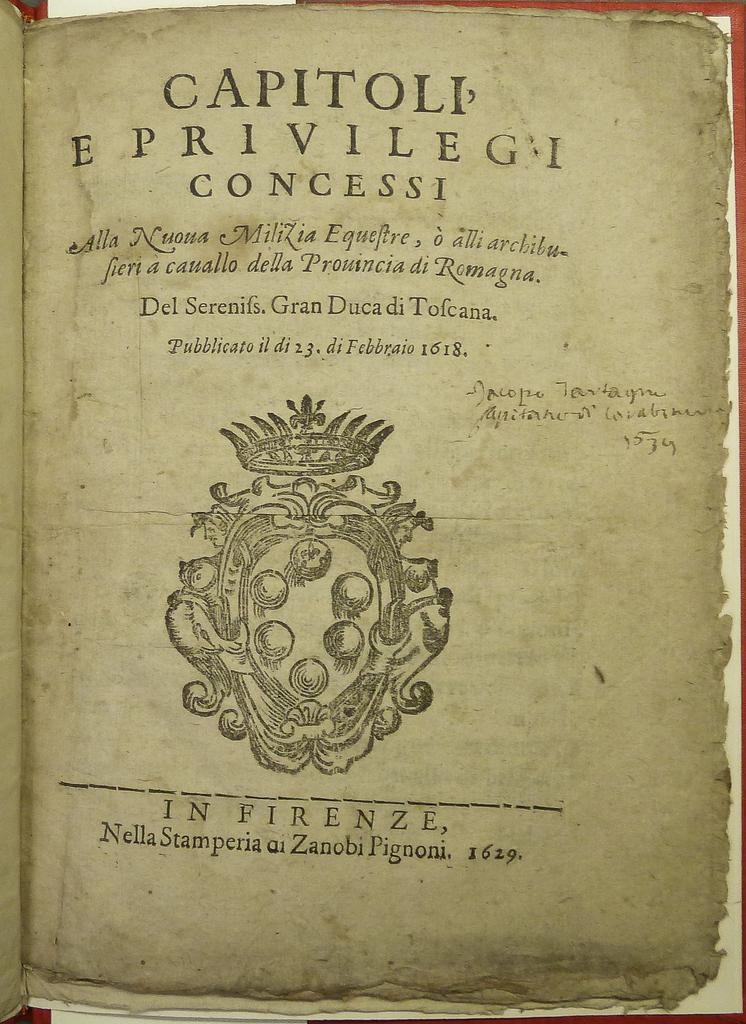<image>
Describe the image concisely. An antique book is open to the cover page that read Capitoli E Privilegi 